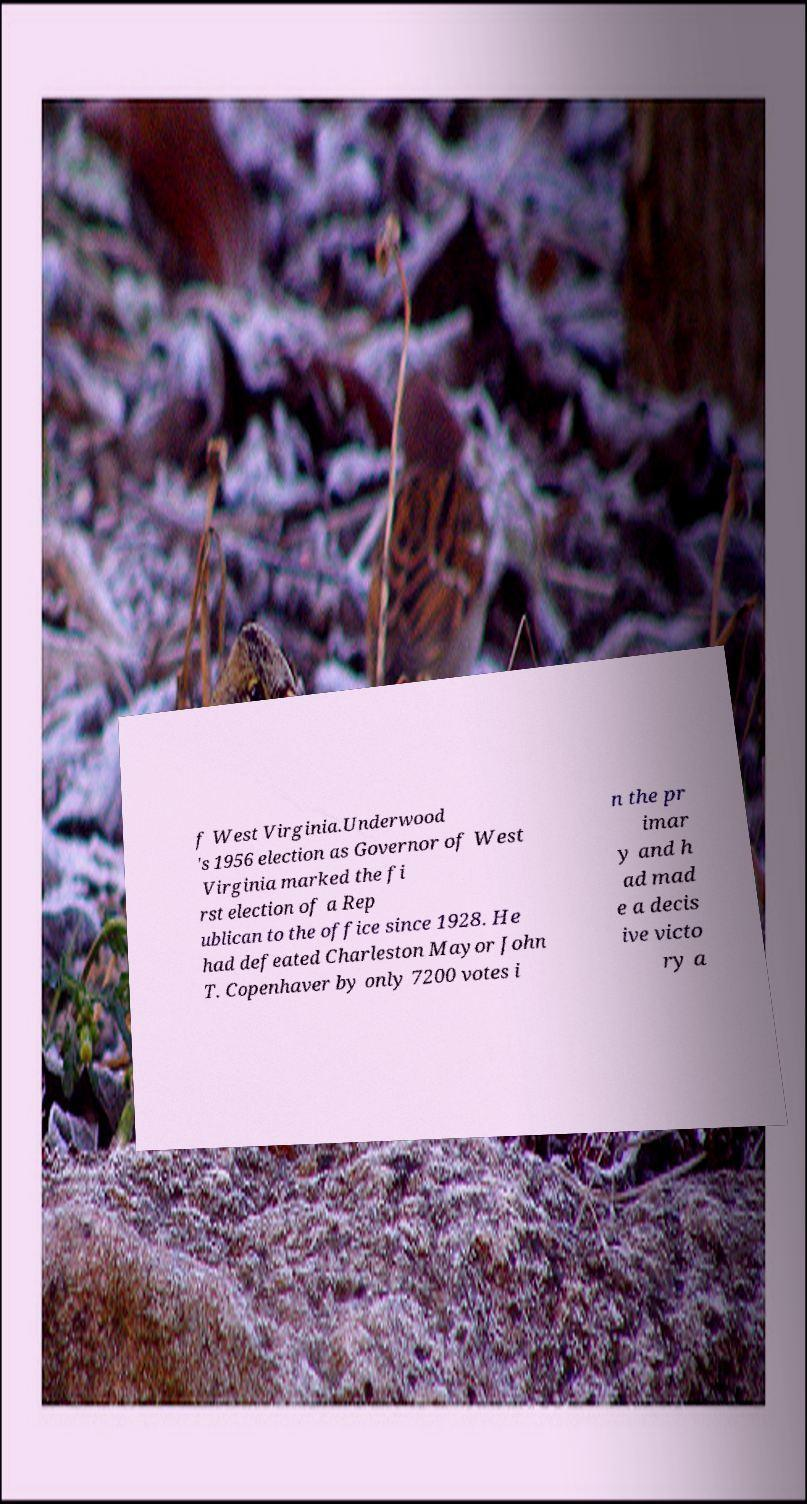For documentation purposes, I need the text within this image transcribed. Could you provide that? f West Virginia.Underwood 's 1956 election as Governor of West Virginia marked the fi rst election of a Rep ublican to the office since 1928. He had defeated Charleston Mayor John T. Copenhaver by only 7200 votes i n the pr imar y and h ad mad e a decis ive victo ry a 